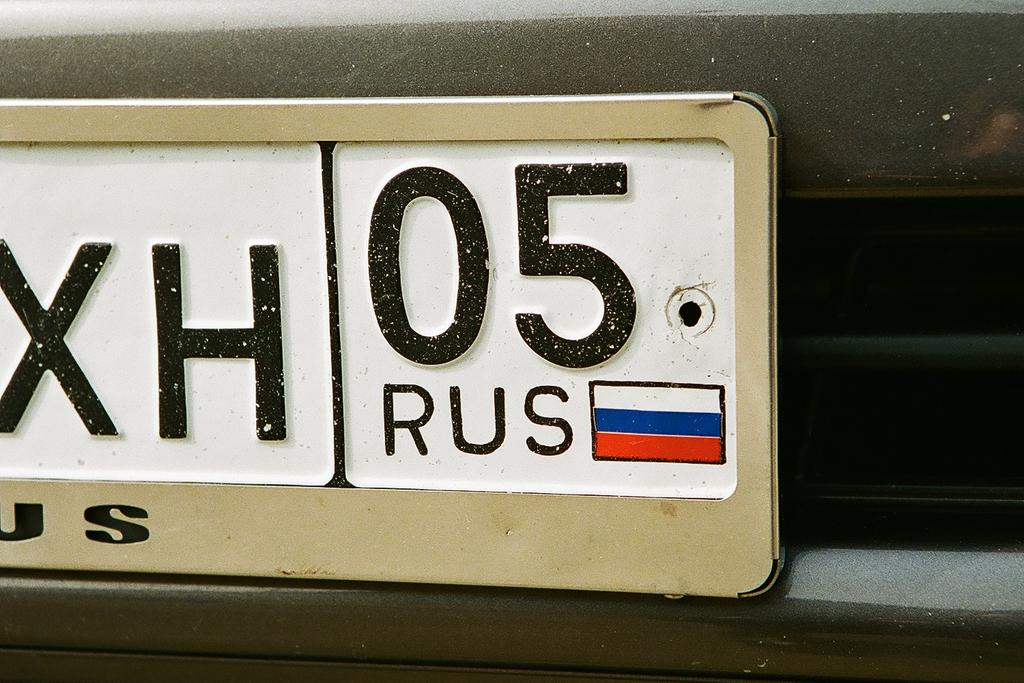<image>
Offer a succinct explanation of the picture presented. A license plate with the number 05 from Rus. 